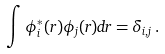Convert formula to latex. <formula><loc_0><loc_0><loc_500><loc_500>\int \phi ^ { * } _ { i } ( { r } ) \phi _ { j } ( { r } ) d { r } = \delta _ { i , j } \, .</formula> 